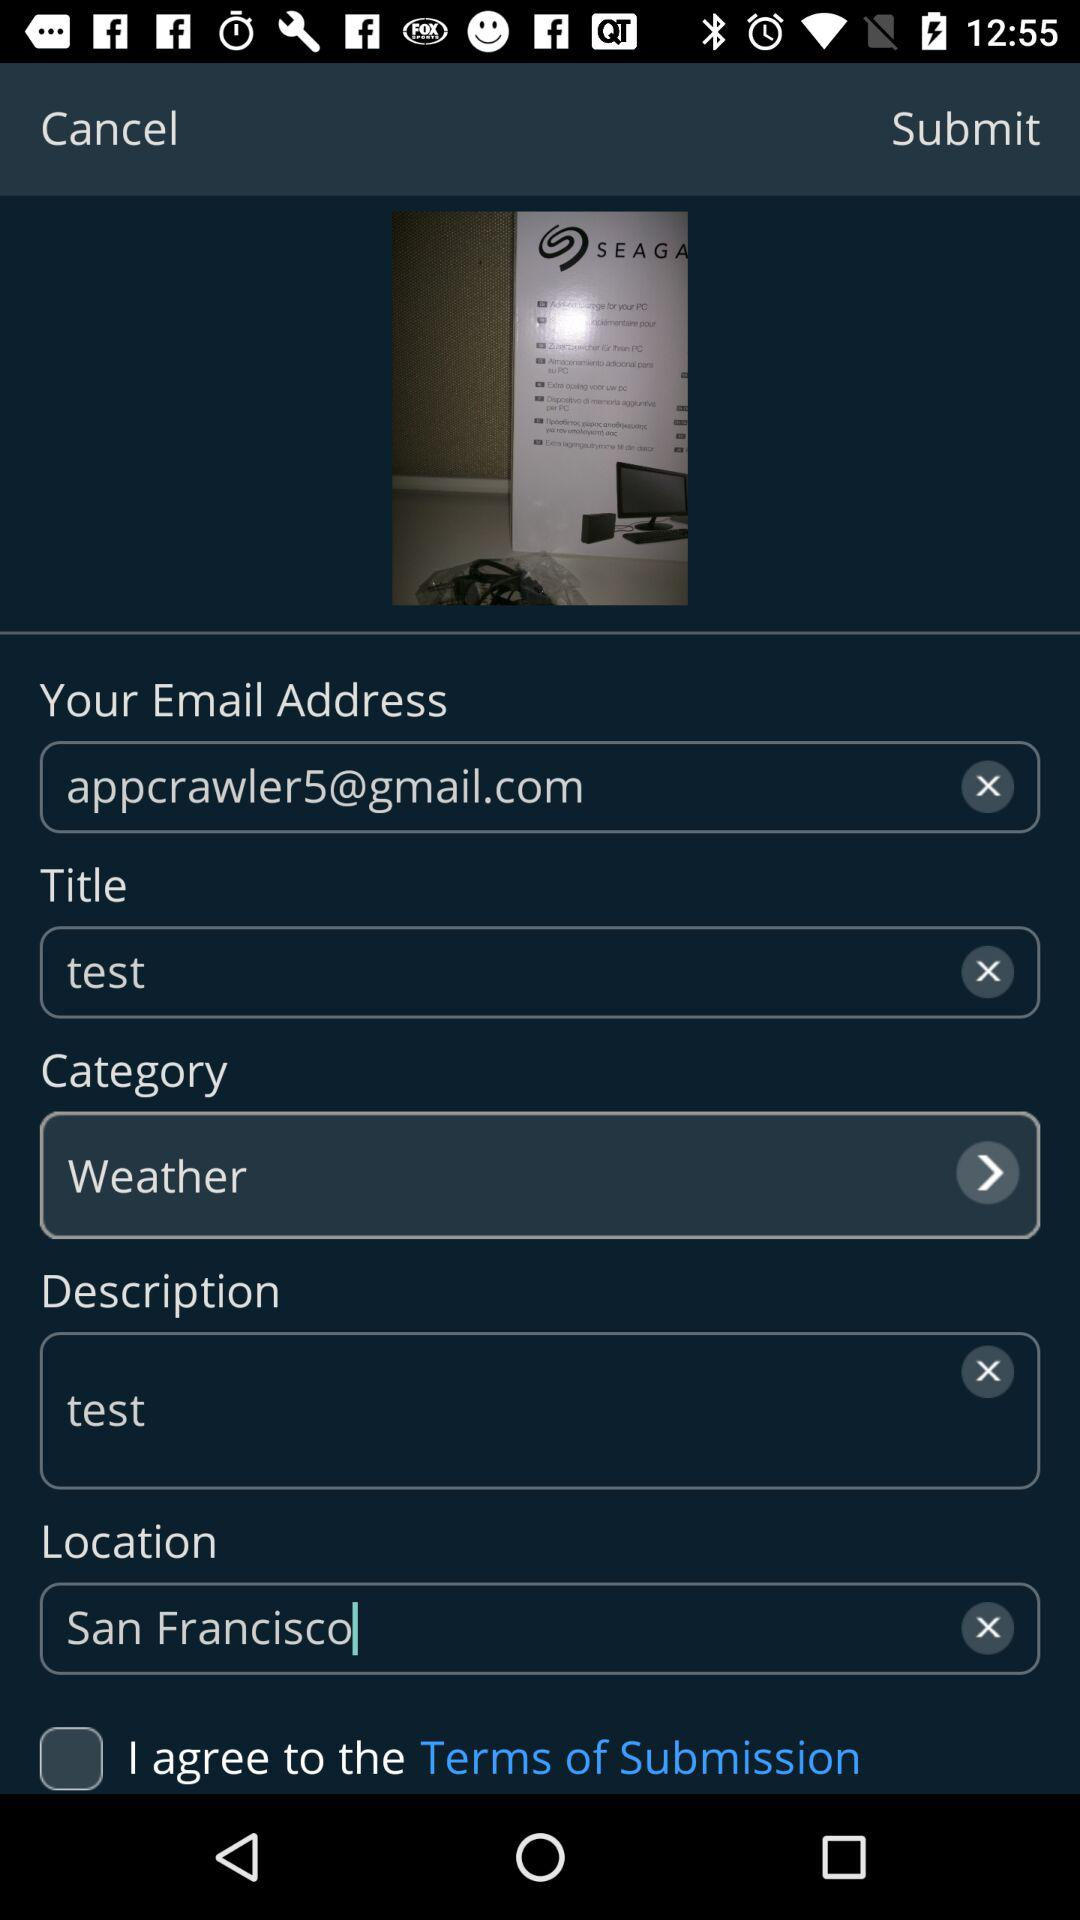How many text inputs have a value of 'test'?
Answer the question using a single word or phrase. 2 